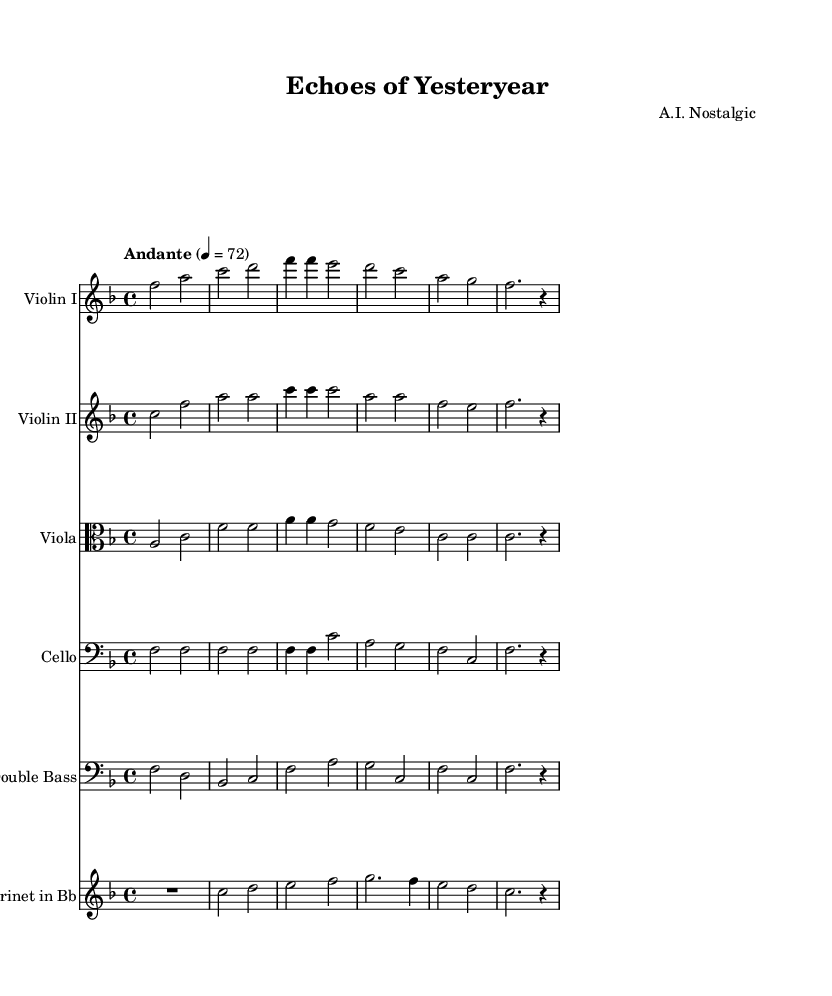What is the key signature of this music? The key signature is F major, which has one flat (B flat). This can be determined from the key signature indicated at the beginning of the sheet music.
Answer: F major What is the time signature of this music? The time signature is 4/4, indicated at the start of the score. This means there are four beats in each measure and a quarter note gets one beat.
Answer: 4/4 What is the tempo marking indicated in the score? The tempo marking is "Andante," which suggests a moderately slow tempo. This is noted above the staff in the tempo indication near the beginning of the sheet music.
Answer: Andante Which instrument plays the highest pitch in this score? The violin I plays the highest pitch, as it is scored higher than the other instruments (violin II, viola, cello, double bass, and clarinet) in the clefs used. The circumferential placement of notes reflects its higher pitch range.
Answer: Violin I How many measures are there in the score? Counting the measures in each staff across all instruments, we find there are a total of 8 measures. This can be done by looking for vertical lines that denote bar lines, which separate the music into measures.
Answer: 8 measures What instrument has the lowest pitch range in this piece? The double bass has the lowest pitch range, as it is tuned lower than the rest of the instruments (violin, viola, cello, and clarinet) and is indicated in the bass clef.
Answer: Double bass 